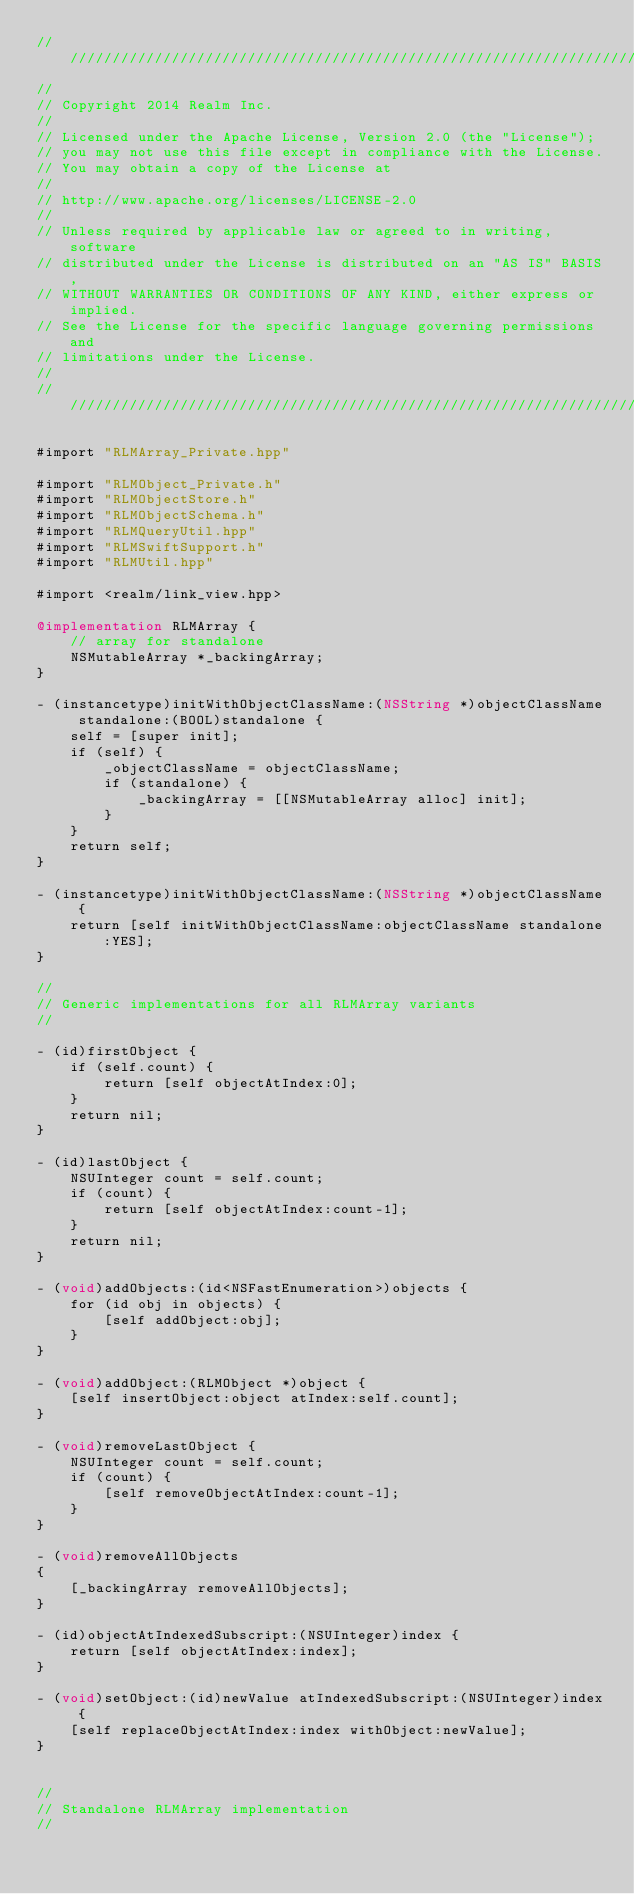<code> <loc_0><loc_0><loc_500><loc_500><_ObjectiveC_>////////////////////////////////////////////////////////////////////////////
//
// Copyright 2014 Realm Inc.
//
// Licensed under the Apache License, Version 2.0 (the "License");
// you may not use this file except in compliance with the License.
// You may obtain a copy of the License at
//
// http://www.apache.org/licenses/LICENSE-2.0
//
// Unless required by applicable law or agreed to in writing, software
// distributed under the License is distributed on an "AS IS" BASIS,
// WITHOUT WARRANTIES OR CONDITIONS OF ANY KIND, either express or implied.
// See the License for the specific language governing permissions and
// limitations under the License.
//
////////////////////////////////////////////////////////////////////////////

#import "RLMArray_Private.hpp"

#import "RLMObject_Private.h"
#import "RLMObjectStore.h"
#import "RLMObjectSchema.h"
#import "RLMQueryUtil.hpp"
#import "RLMSwiftSupport.h"
#import "RLMUtil.hpp"

#import <realm/link_view.hpp>

@implementation RLMArray {
    // array for standalone
    NSMutableArray *_backingArray;
}

- (instancetype)initWithObjectClassName:(NSString *)objectClassName standalone:(BOOL)standalone {
    self = [super init];
    if (self) {
        _objectClassName = objectClassName;
        if (standalone) {
            _backingArray = [[NSMutableArray alloc] init];
        }
    }
    return self;
}

- (instancetype)initWithObjectClassName:(NSString *)objectClassName {
    return [self initWithObjectClassName:objectClassName standalone:YES];
}

//
// Generic implementations for all RLMArray variants
//

- (id)firstObject {
    if (self.count) {
        return [self objectAtIndex:0];
    }
    return nil;
}

- (id)lastObject {
    NSUInteger count = self.count;
    if (count) {
        return [self objectAtIndex:count-1];
    }
    return nil;
}

- (void)addObjects:(id<NSFastEnumeration>)objects {
    for (id obj in objects) {
        [self addObject:obj];
    }
}

- (void)addObject:(RLMObject *)object {
    [self insertObject:object atIndex:self.count];
}

- (void)removeLastObject {
    NSUInteger count = self.count;
    if (count) {
        [self removeObjectAtIndex:count-1];
    }
}

- (void)removeAllObjects
{
    [_backingArray removeAllObjects];
}

- (id)objectAtIndexedSubscript:(NSUInteger)index {
    return [self objectAtIndex:index];
}

- (void)setObject:(id)newValue atIndexedSubscript:(NSUInteger)index {
    [self replaceObjectAtIndex:index withObject:newValue];
}


//
// Standalone RLMArray implementation
//
</code> 